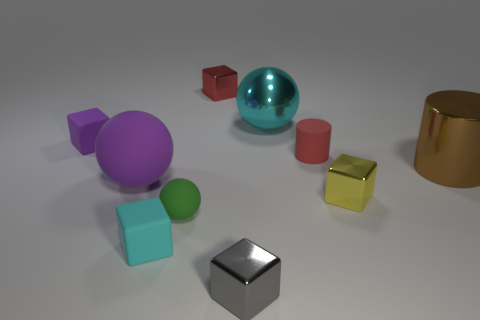Subtract all tiny spheres. How many spheres are left? 2 Subtract all purple spheres. How many spheres are left? 2 Subtract 1 blocks. How many blocks are left? 4 Subtract all cylinders. How many objects are left? 8 Subtract all yellow cubes. Subtract all gray balls. How many cubes are left? 4 Add 1 tiny red shiny things. How many tiny red shiny things exist? 2 Subtract 0 gray cylinders. How many objects are left? 10 Subtract all tiny red cylinders. Subtract all brown metal cylinders. How many objects are left? 8 Add 8 tiny gray shiny objects. How many tiny gray shiny objects are left? 9 